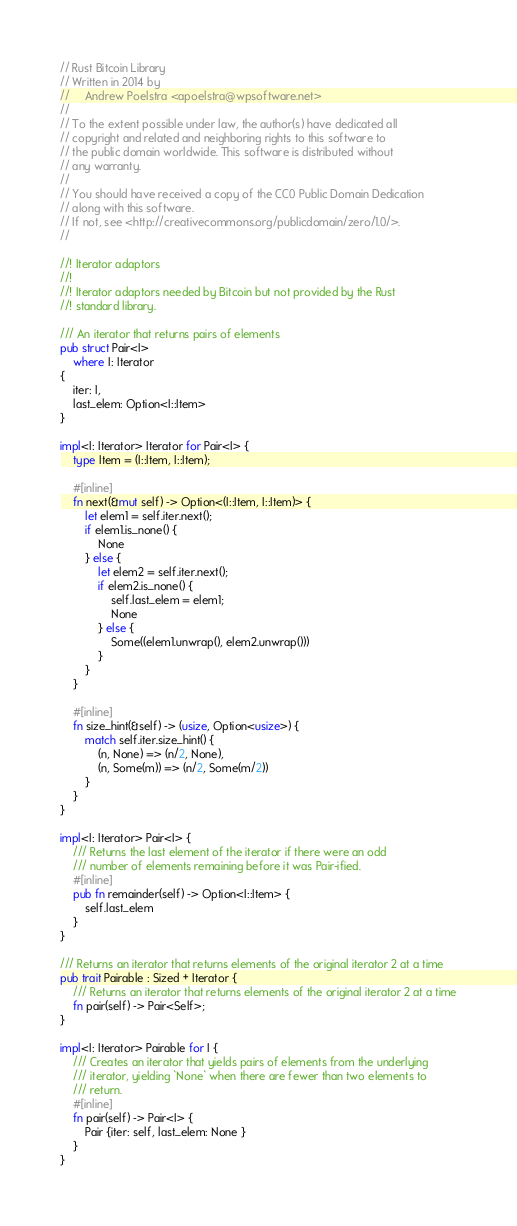Convert code to text. <code><loc_0><loc_0><loc_500><loc_500><_Rust_>// Rust Bitcoin Library
// Written in 2014 by
//     Andrew Poelstra <apoelstra@wpsoftware.net>
//
// To the extent possible under law, the author(s) have dedicated all
// copyright and related and neighboring rights to this software to
// the public domain worldwide. This software is distributed without
// any warranty.
//
// You should have received a copy of the CC0 Public Domain Dedication
// along with this software.
// If not, see <http://creativecommons.org/publicdomain/zero/1.0/>.
//

//! Iterator adaptors
//!
//! Iterator adaptors needed by Bitcoin but not provided by the Rust
//! standard library.

/// An iterator that returns pairs of elements
pub struct Pair<I>
    where I: Iterator
{
    iter: I,
    last_elem: Option<I::Item>
}

impl<I: Iterator> Iterator for Pair<I> {
    type Item = (I::Item, I::Item);

    #[inline]
    fn next(&mut self) -> Option<(I::Item, I::Item)> {
        let elem1 = self.iter.next();
        if elem1.is_none() {
            None
        } else {
            let elem2 = self.iter.next();
            if elem2.is_none() {
                self.last_elem = elem1;
                None
            } else {
                Some((elem1.unwrap(), elem2.unwrap()))
            }
        }
    }

    #[inline]
    fn size_hint(&self) -> (usize, Option<usize>) {
        match self.iter.size_hint() {
            (n, None) => (n/2, None),
            (n, Some(m)) => (n/2, Some(m/2))
        }
    }
}

impl<I: Iterator> Pair<I> {
    /// Returns the last element of the iterator if there were an odd
    /// number of elements remaining before it was Pair-ified.
    #[inline]
    pub fn remainder(self) -> Option<I::Item> {
        self.last_elem
    }
}

/// Returns an iterator that returns elements of the original iterator 2 at a time
pub trait Pairable : Sized + Iterator {
    /// Returns an iterator that returns elements of the original iterator 2 at a time
    fn pair(self) -> Pair<Self>;
}

impl<I: Iterator> Pairable for I {
    /// Creates an iterator that yields pairs of elements from the underlying
    /// iterator, yielding `None` when there are fewer than two elements to
    /// return.
    #[inline]
    fn pair(self) -> Pair<I> {
        Pair {iter: self, last_elem: None }
    }
}

</code> 